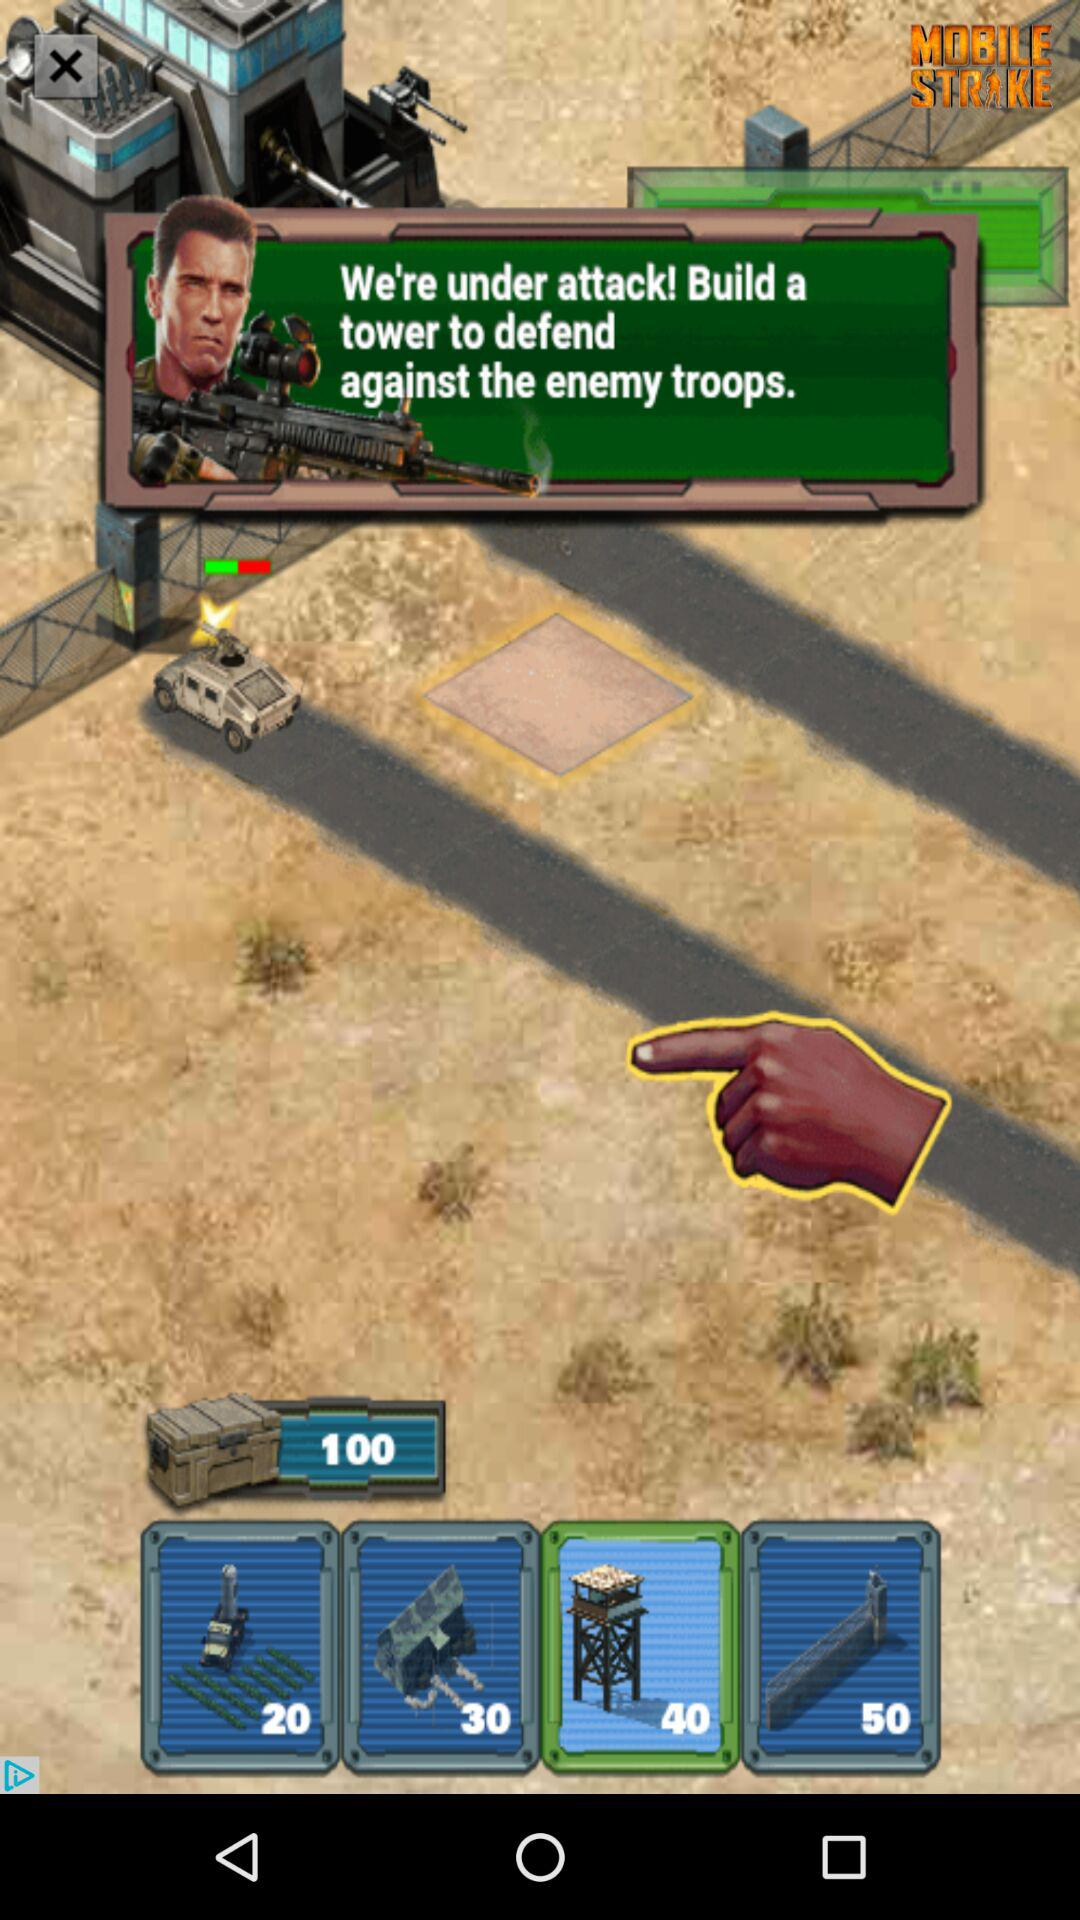How much more does the 50 cost than the 40?
Answer the question using a single word or phrase. 10 